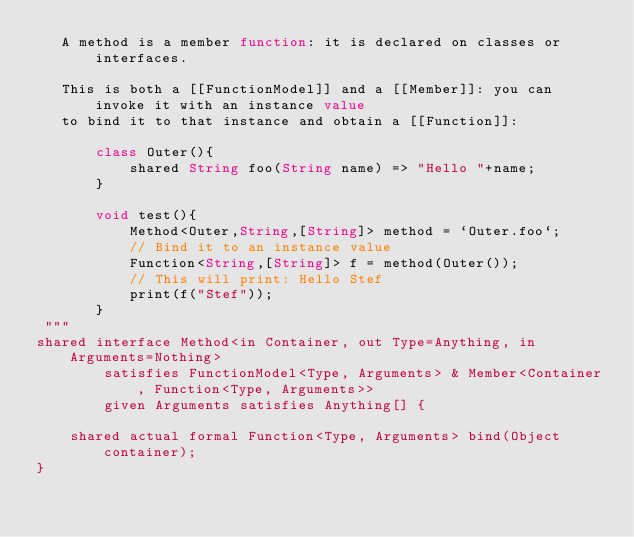Convert code to text. <code><loc_0><loc_0><loc_500><loc_500><_Ceylon_>   A method is a member function: it is declared on classes or interfaces.
   
   This is both a [[FunctionModel]] and a [[Member]]: you can invoke it with an instance value
   to bind it to that instance and obtain a [[Function]]:
   
       class Outer(){
           shared String foo(String name) => "Hello "+name;
       }
       
       void test(){
           Method<Outer,String,[String]> method = `Outer.foo`;
           // Bind it to an instance value
           Function<String,[String]> f = method(Outer());
           // This will print: Hello Stef
           print(f("Stef"));
       }
 """
shared interface Method<in Container, out Type=Anything, in Arguments=Nothing>
        satisfies FunctionModel<Type, Arguments> & Member<Container, Function<Type, Arguments>>
        given Arguments satisfies Anything[] {

    shared actual formal Function<Type, Arguments> bind(Object container);
}
</code> 